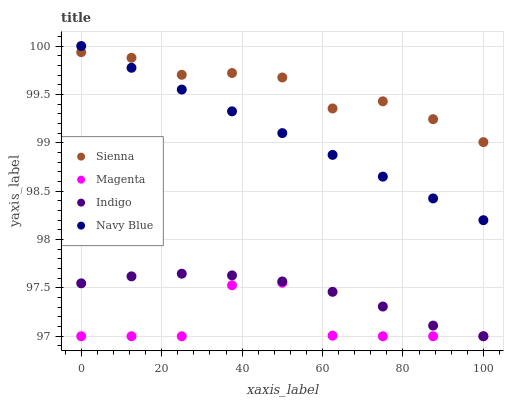Does Magenta have the minimum area under the curve?
Answer yes or no. Yes. Does Sienna have the maximum area under the curve?
Answer yes or no. Yes. Does Navy Blue have the minimum area under the curve?
Answer yes or no. No. Does Navy Blue have the maximum area under the curve?
Answer yes or no. No. Is Navy Blue the smoothest?
Answer yes or no. Yes. Is Magenta the roughest?
Answer yes or no. Yes. Is Magenta the smoothest?
Answer yes or no. No. Is Navy Blue the roughest?
Answer yes or no. No. Does Magenta have the lowest value?
Answer yes or no. Yes. Does Navy Blue have the lowest value?
Answer yes or no. No. Does Navy Blue have the highest value?
Answer yes or no. Yes. Does Magenta have the highest value?
Answer yes or no. No. Is Magenta less than Sienna?
Answer yes or no. Yes. Is Sienna greater than Indigo?
Answer yes or no. Yes. Does Navy Blue intersect Sienna?
Answer yes or no. Yes. Is Navy Blue less than Sienna?
Answer yes or no. No. Is Navy Blue greater than Sienna?
Answer yes or no. No. Does Magenta intersect Sienna?
Answer yes or no. No. 